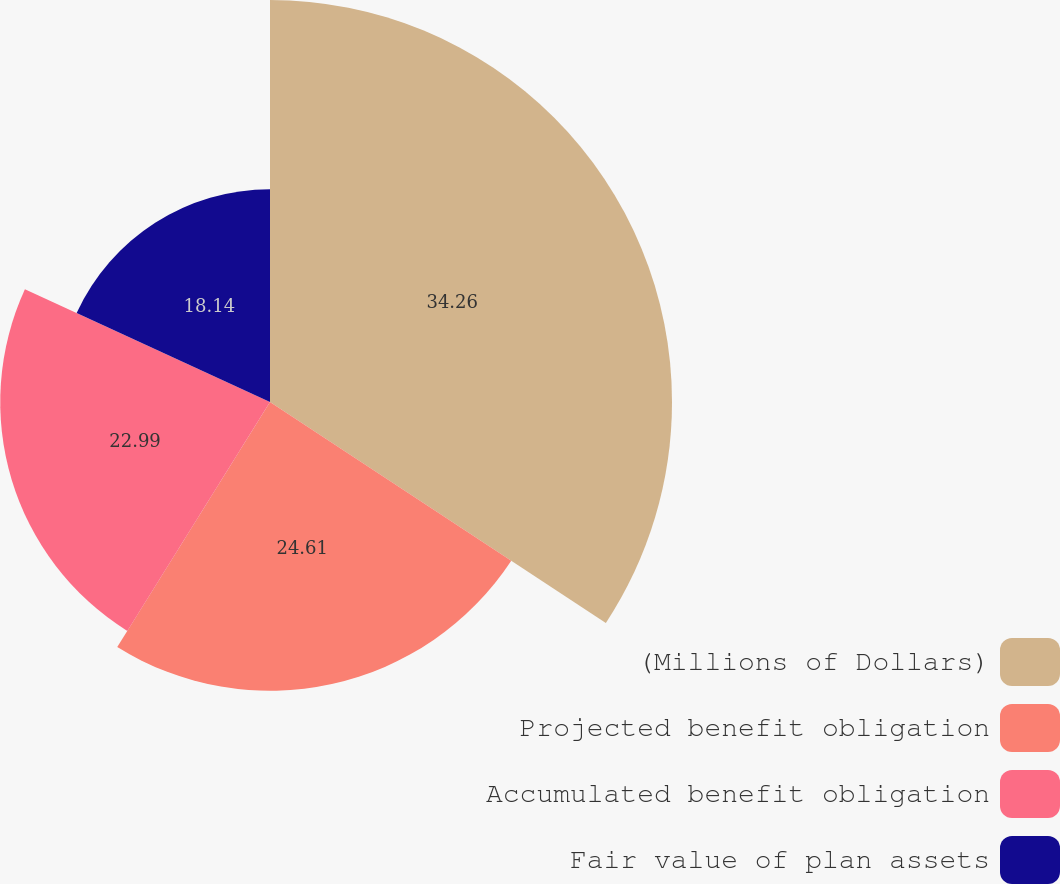<chart> <loc_0><loc_0><loc_500><loc_500><pie_chart><fcel>(Millions of Dollars)<fcel>Projected benefit obligation<fcel>Accumulated benefit obligation<fcel>Fair value of plan assets<nl><fcel>34.26%<fcel>24.61%<fcel>22.99%<fcel>18.14%<nl></chart> 